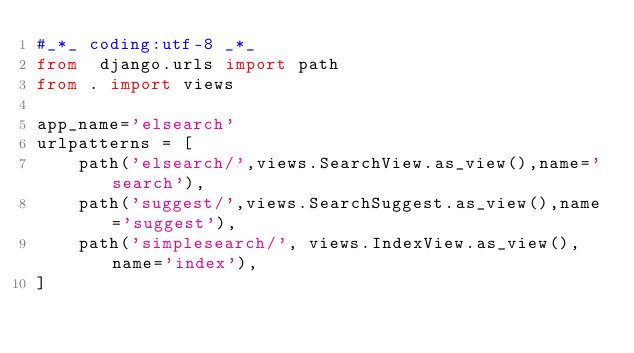<code> <loc_0><loc_0><loc_500><loc_500><_Python_>#_*_ coding:utf-8 _*_
from  django.urls import path
from . import views

app_name='elsearch'
urlpatterns = [
    path('elsearch/',views.SearchView.as_view(),name='search'),
    path('suggest/',views.SearchSuggest.as_view(),name='suggest'),
    path('simplesearch/', views.IndexView.as_view(), name='index'),
]




</code> 